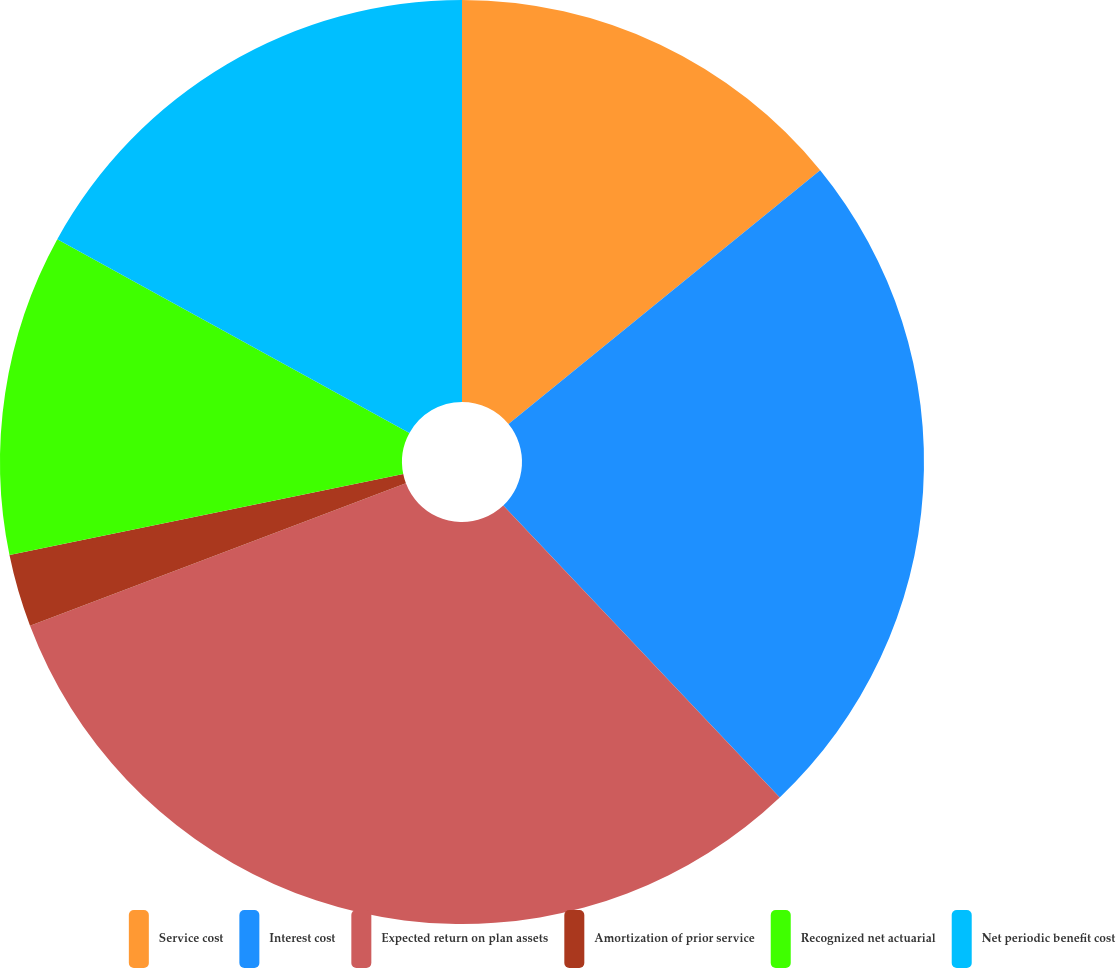Convert chart to OTSL. <chart><loc_0><loc_0><loc_500><loc_500><pie_chart><fcel>Service cost<fcel>Interest cost<fcel>Expected return on plan assets<fcel>Amortization of prior service<fcel>Recognized net actuarial<fcel>Net periodic benefit cost<nl><fcel>14.12%<fcel>23.81%<fcel>31.3%<fcel>2.54%<fcel>11.24%<fcel>16.99%<nl></chart> 